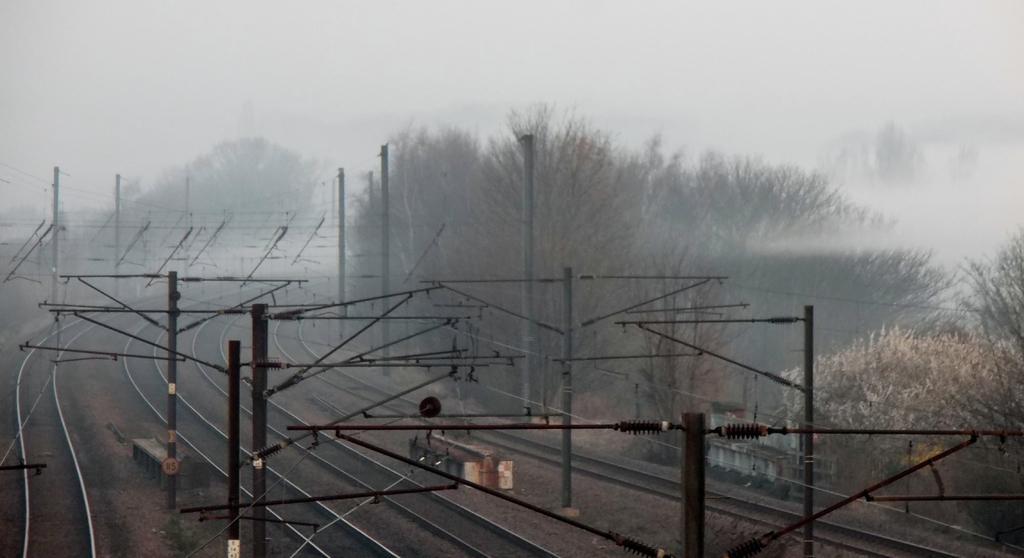Could you give a brief overview of what you see in this image? In this image there are railway tracks, above the tracks there are a few metal structures and some utility poles. In the background there are trees and the sky. 